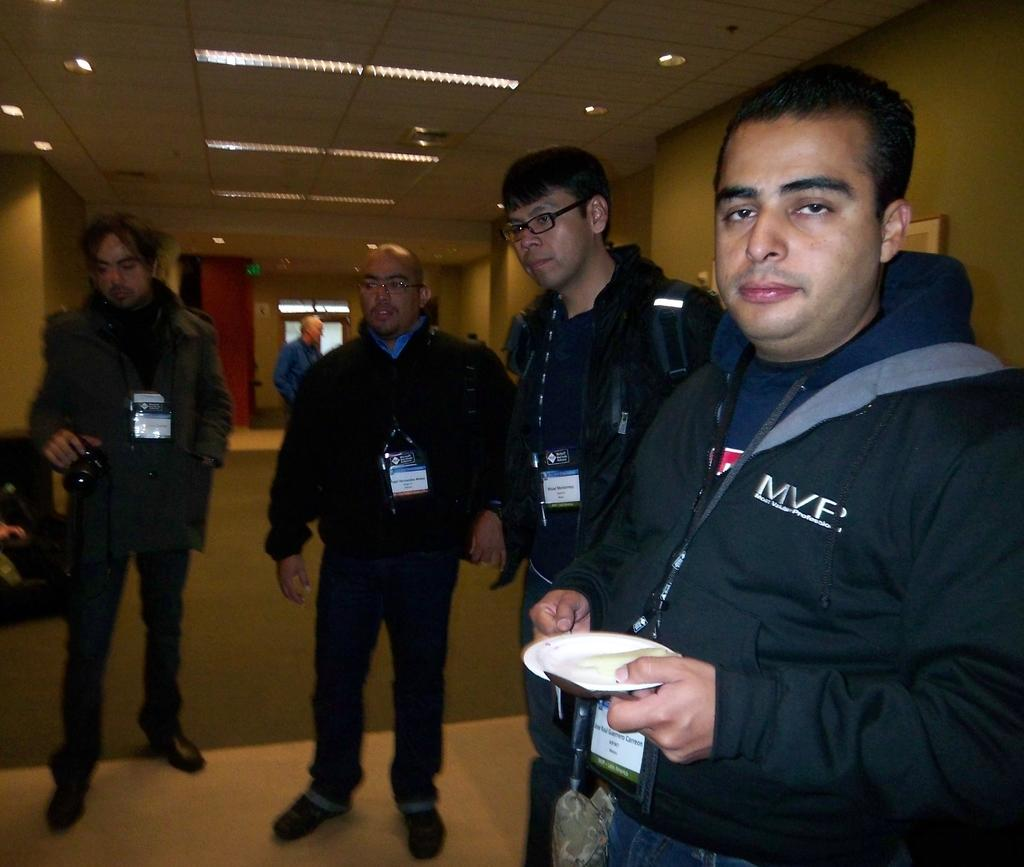What are the people in the image doing? The people in the image are standing on the surface. Can you describe the person on the left side of the image? The person on the left side of the image is holding a camera. What is present on the roof in the image? There are light arrangements on the roof in the image. What type of tray is being used to increase the speed of the road in the image? There is no tray or road present in the image, and therefore no such activity can be observed. 